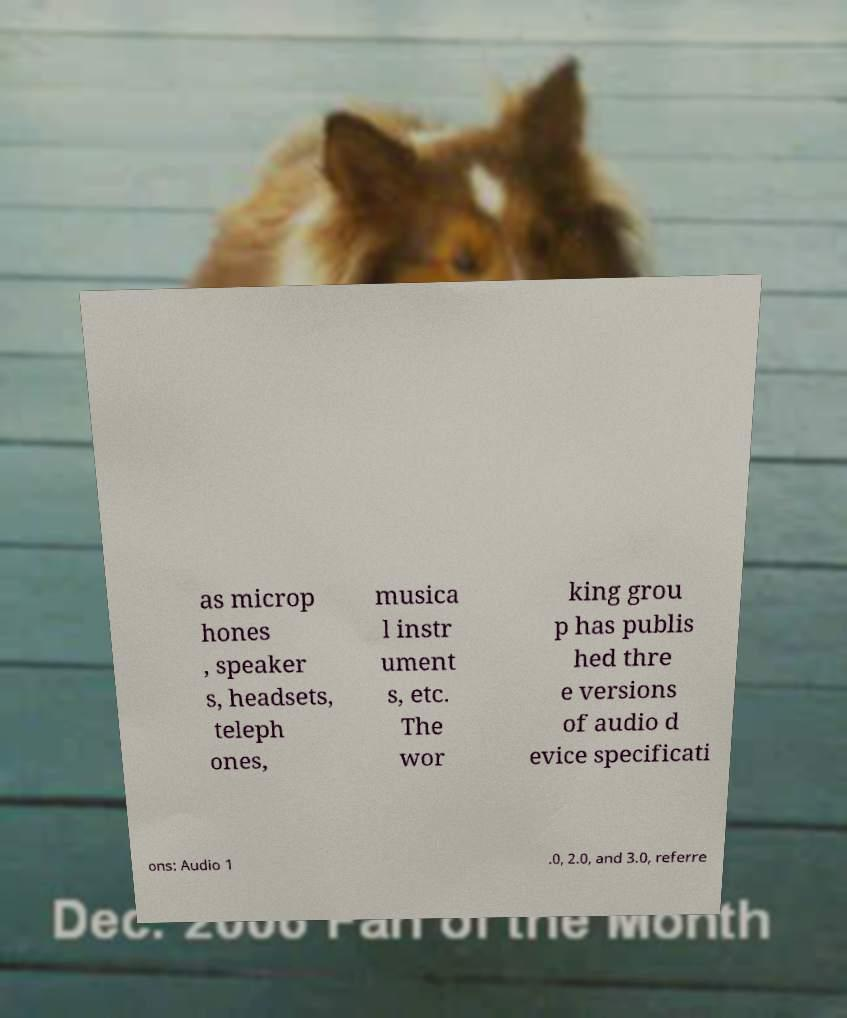Can you accurately transcribe the text from the provided image for me? as microp hones , speaker s, headsets, teleph ones, musica l instr ument s, etc. The wor king grou p has publis hed thre e versions of audio d evice specificati ons: Audio 1 .0, 2.0, and 3.0, referre 